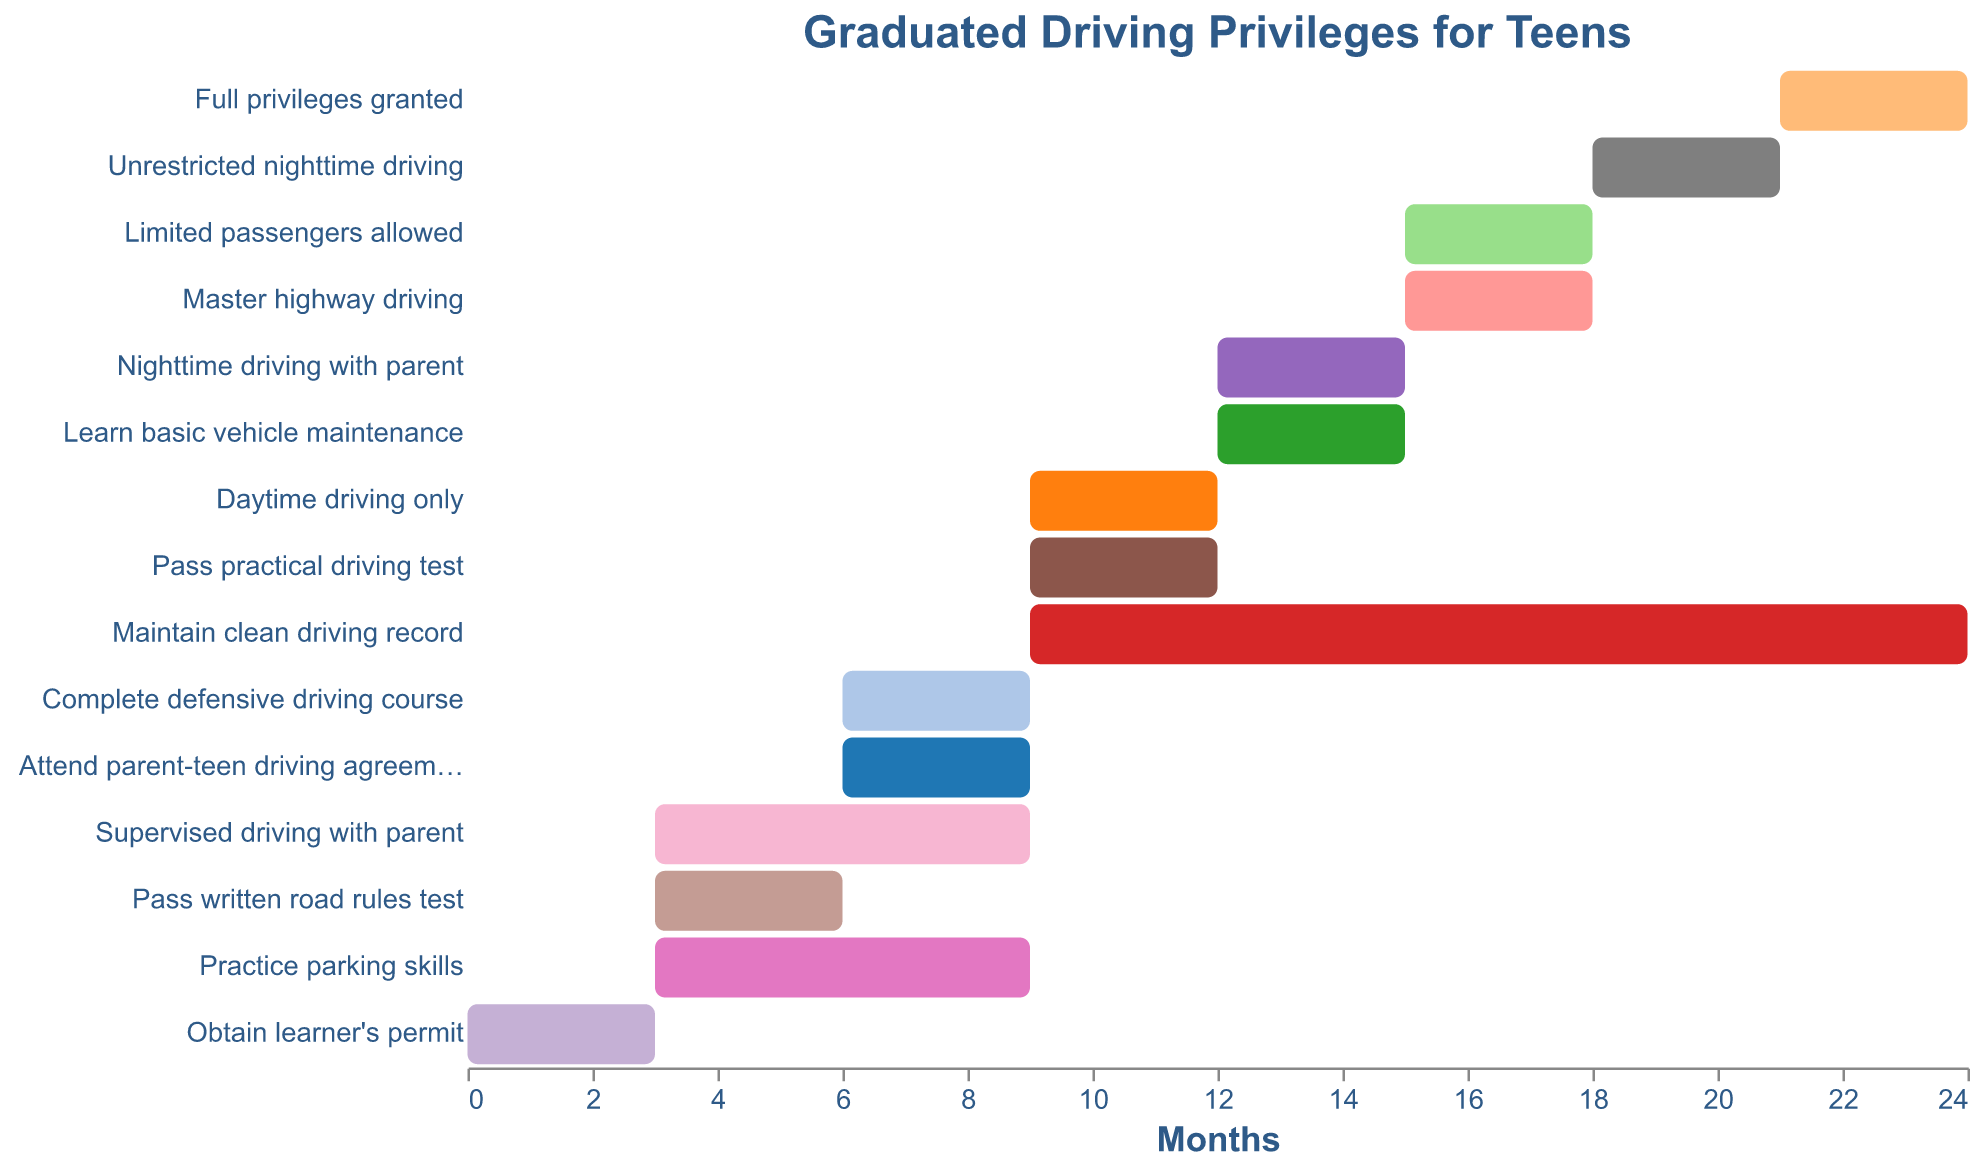What's the total duration to achieve full driving privileges from obtaining the learner's permit? To find the total duration, look at the "Start" and "End" values for the "Full privileges granted" task. The "Start" value is 0 months (when the learner's permit is obtained), and the "End" value for full privileges is 24 months. Subtract 0 from 24: 24 - 0 = 24 months.
Answer: 24 months Which tasks overlap with the "Maintain clean driving record" requirement? The "Maintain clean driving record" task spans from month 9 to 24. Check which other tasks have time spans that intersect with this period. These tasks are "Daytime driving only" (9-12), "Nighttime driving with parent" (12-15), "Limited passengers allowed" (15-18), "Unrestricted nighttime driving" (18-21), "Complete defensive driving course" (6-9), "Learn basic vehicle maintenance" (12-15), and "Master highway driving" (15-18).
Answer: "Daytime driving only", "Nighttime driving with parent", "Limited passengers allowed", "Unrestricted nighttime driving", "Complete defensive driving course", "Learn basic vehicle maintenance", "Master highway driving" What is the duration of the "Supervised driving with parent" task? The "Supervised driving with parent" task starts at month 3 and ends at month 9. Subtract the start month from the end month: 9 - 3 = 6 months.
Answer: 6 months How much time is allocated to "Pass practical driving test" after "Pass written road rules test"? "Pass written road rules test" spans from month 3 to 6, while "Pass practical driving test" spans from month 9 to 12. To find the time allocated between them, subtract the end of "Pass written road rules test" from the start of "Pass practical driving test": 9 - 6 = 3 months. Additionally, you can note that "Practice parking skills" overlaps both periods from month 3 to 9.
Answer: 3 months Which task starts immediately after "Supervised driving with parent"? The "Supervised driving with parent" task ends at month 9. The next task that starts at month 9 is "Daytime driving only".
Answer: "Daytime driving only" Is "Unrestricted nighttime driving" allowed before "Master highway driving"? Yes, compare the periods for "Unrestricted nighttime driving" (months 18-21) and "Master highway driving" (months 15-18). "Unrestricted nighttime driving" starts immediately after "Master highway driving".
Answer: Yes What tasks are scheduled for month 6? To determine which tasks are scheduled for month 6, identify tasks that span this period. These tasks are "Complete defensive driving course" (6-9), "Attend parent-teen driving agreement workshop" (6-9), "Supervised driving with parent" (3-9), "Maintain clean driving record" (9-24), "Practice parking skills" (3-9), and "Pass written road rules test" (3-6).
Answer: "Complete defensive driving course"; "Attend parent-teen driving agreement workshop"; "Supervised driving with parent"; "Maintain clean driving record"; "Practice parking skills"; "Pass written road rules test" Which task has the longest duration? Compare the durations of each task by subtracting the "Start" values from the "End" values. "Maintain clean driving record" has the longest duration of 15 months (24 - 9 = 15 months).
Answer: "Maintain clean driving record" Is there any task that runs concurrently with "Attend parent-teen driving agreement workshop"? "Attend parent-teen driving agreement workshop" spans from month 6 to 9. Tasks that run concurrently are "Complete defensive driving course" (6-9), "Supervised driving with parent" (3-9), "Practice parking skills" (3-9), "Pass written road rules test" (3-6), and "Daytime driving only" (9-12 starts at the end).
Answer: "Complete defensive driving course"; "Supervised driving with parent"; "Practice parking skills"; "Pass written road rules test" When does "Nighttime driving with parent" start and end? The "Nighttime driving with parent" task starts at month 12 and ends at month 15.
Answer: Starts at 12, ends at 15 